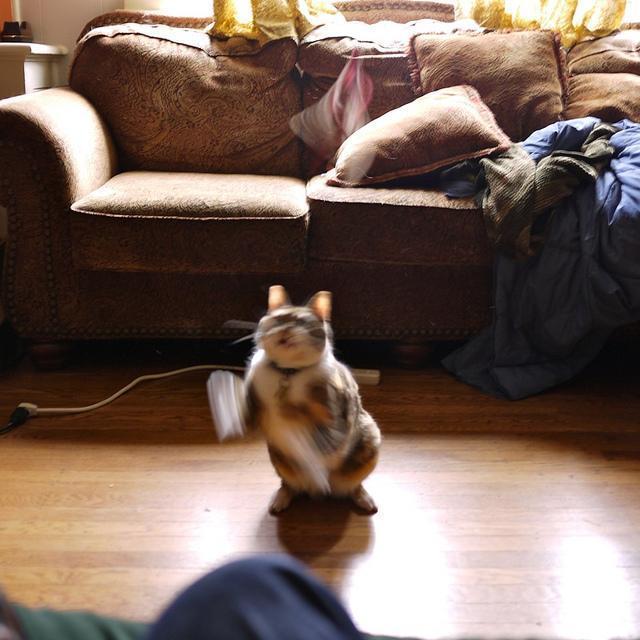How many cats are there?
Give a very brief answer. 1. 